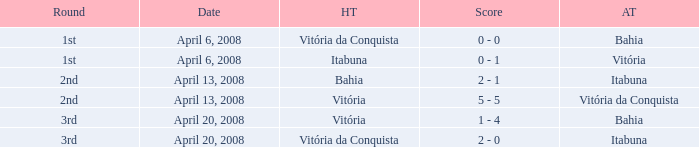What is the name of the home team on April 13, 2008 when Itabuna was the away team? Bahia. 